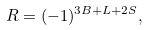Convert formula to latex. <formula><loc_0><loc_0><loc_500><loc_500>R = ( - 1 ) ^ { 3 B + L + 2 S } ,</formula> 